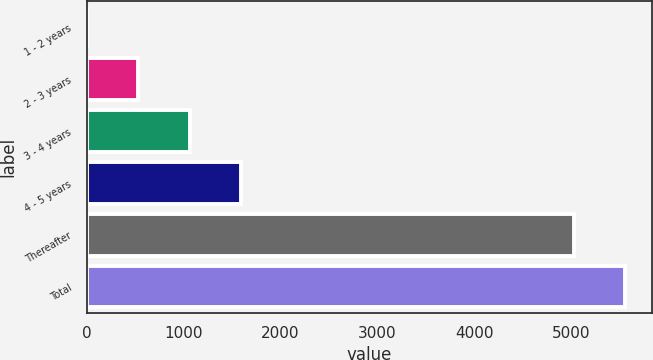Convert chart. <chart><loc_0><loc_0><loc_500><loc_500><bar_chart><fcel>1 - 2 years<fcel>2 - 3 years<fcel>3 - 4 years<fcel>4 - 5 years<fcel>Thereafter<fcel>Total<nl><fcel>9<fcel>535.7<fcel>1062.4<fcel>1589.1<fcel>5030<fcel>5556.7<nl></chart> 